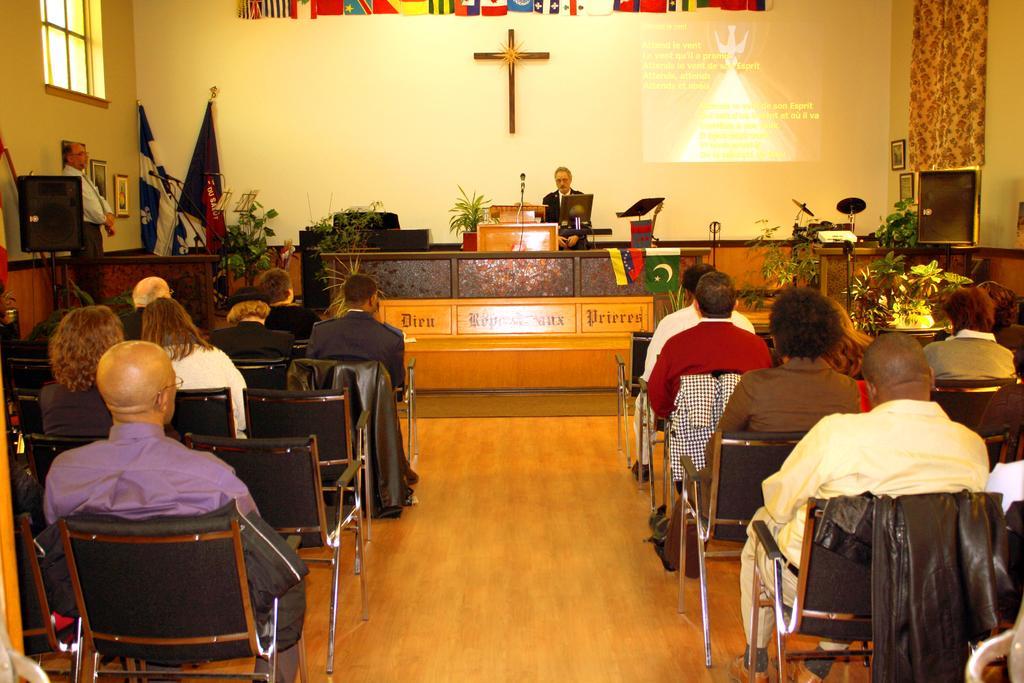In one or two sentences, can you explain what this image depicts? It is a church,inside the church the people sitting in the black color chairs in front of them there is a table, the father of the church is standing there, to right side there is a project being projected on the wall, to the left side corner there is another person standing spectating beside him there are some photo frames and also two flags, there is a wall in the background it is of cream color. 